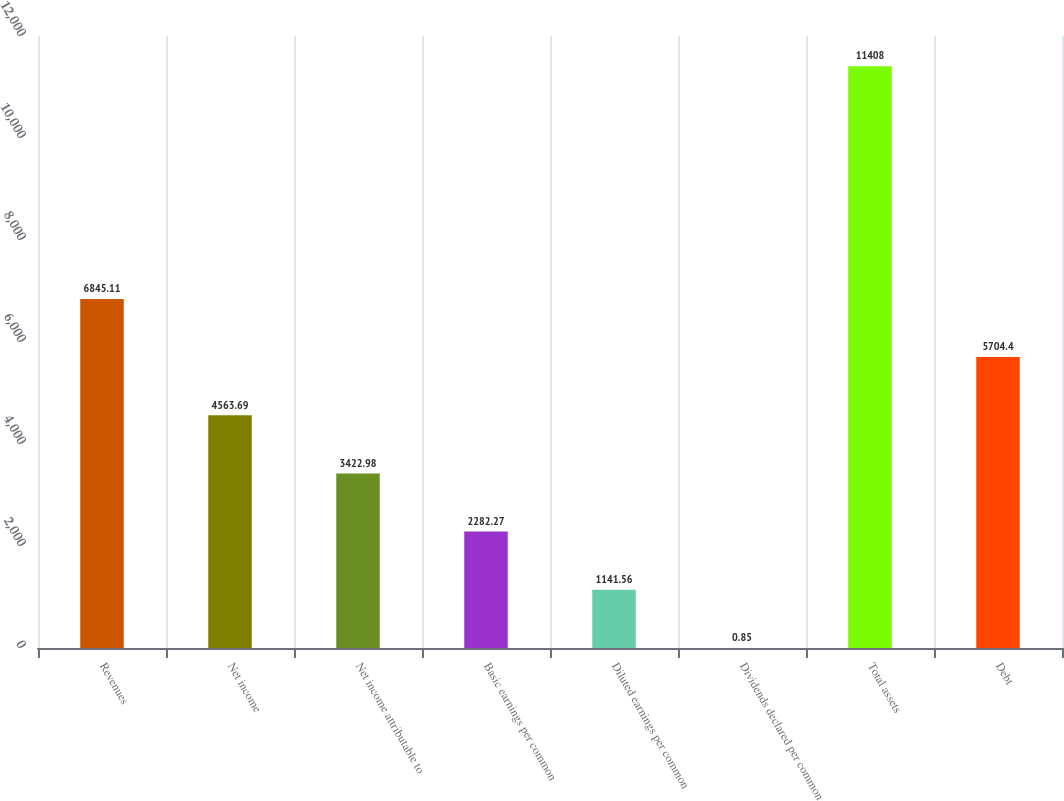<chart> <loc_0><loc_0><loc_500><loc_500><bar_chart><fcel>Revenues<fcel>Net income<fcel>Net income attributable to<fcel>Basic earnings per common<fcel>Diluted earnings per common<fcel>Dividends declared per common<fcel>Total assets<fcel>Debt<nl><fcel>6845.11<fcel>4563.69<fcel>3422.98<fcel>2282.27<fcel>1141.56<fcel>0.85<fcel>11408<fcel>5704.4<nl></chart> 